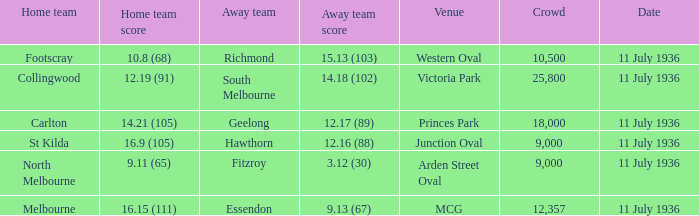What Away team got a team score of 12.16 (88)? Hawthorn. 